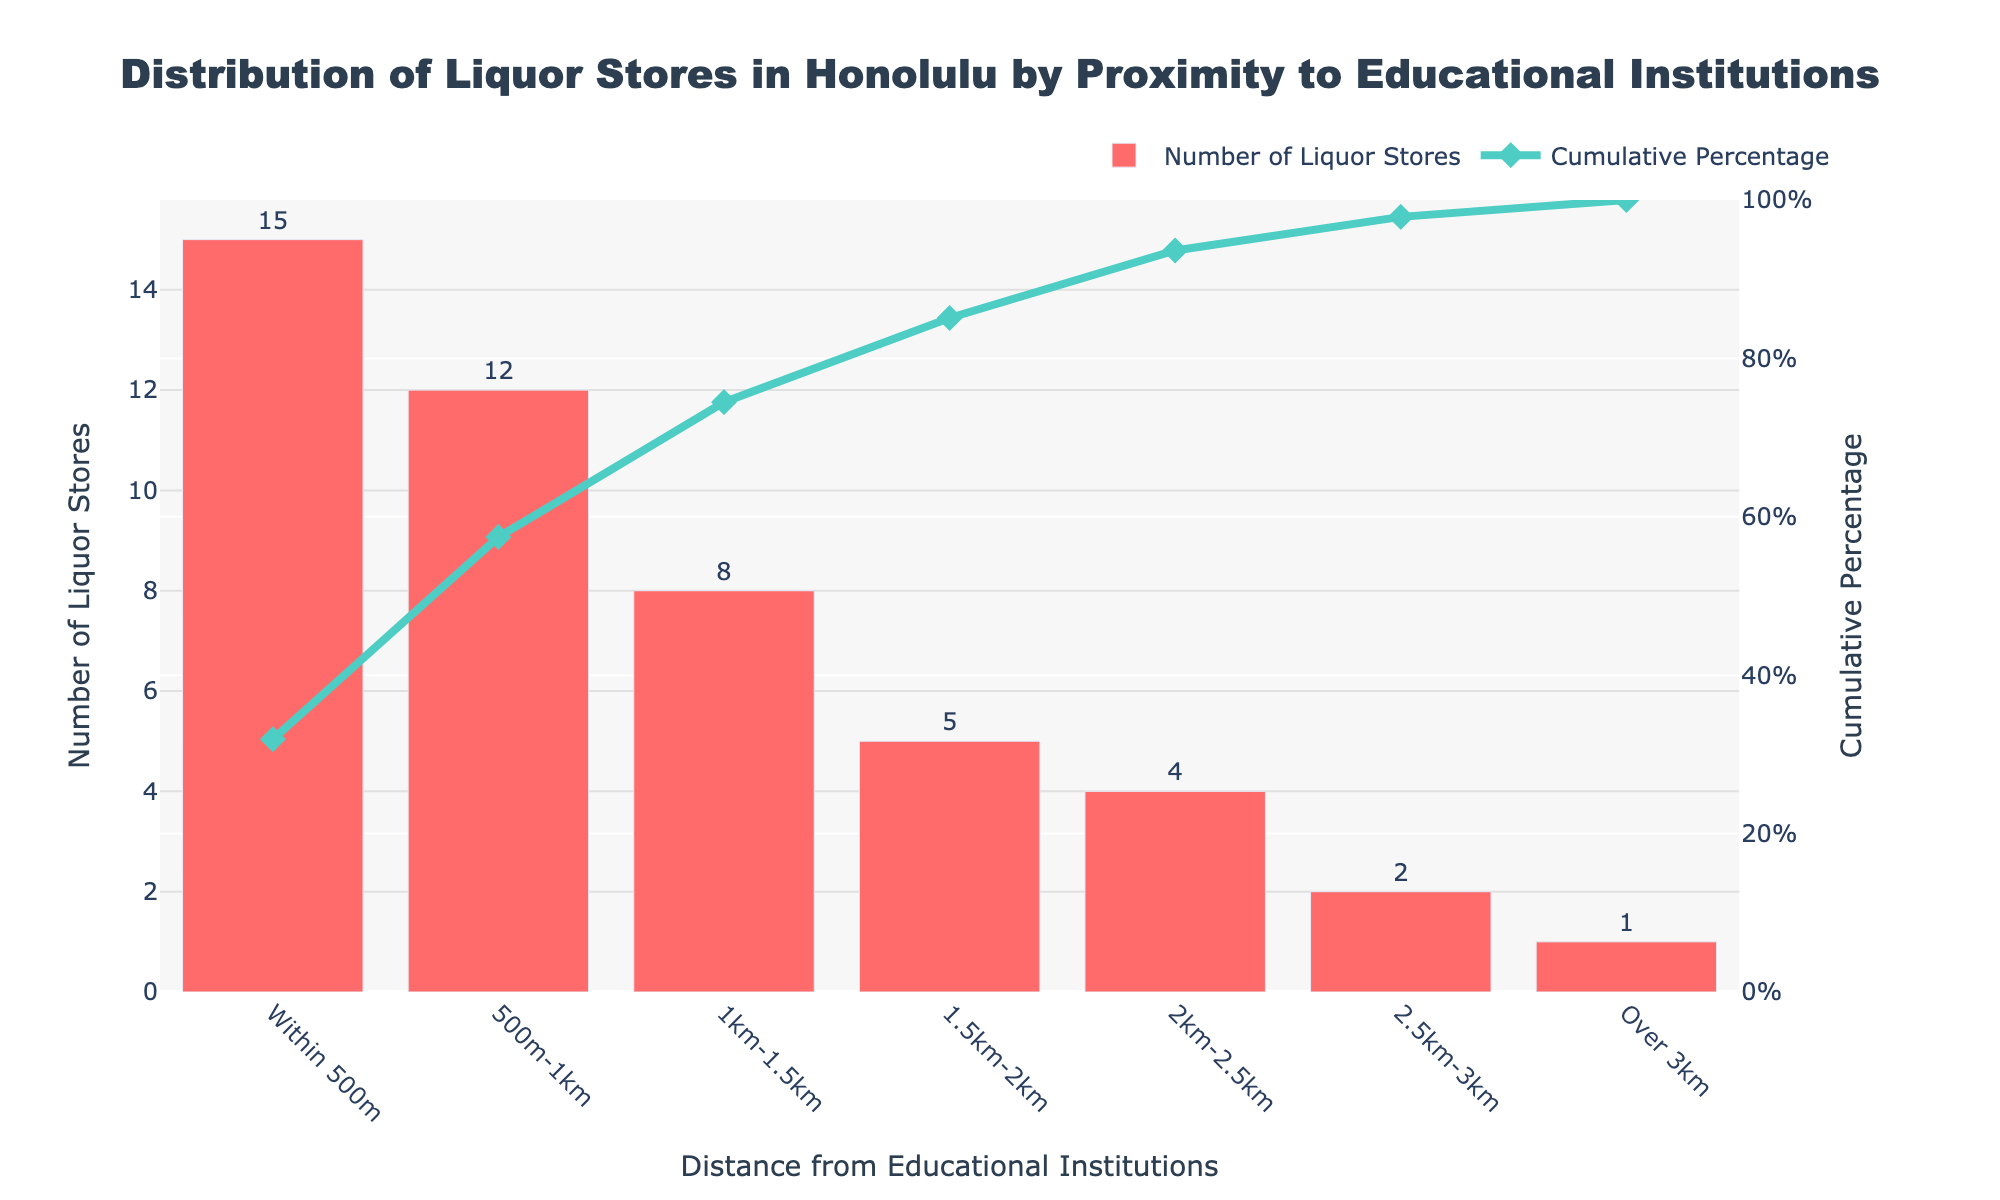What is the title of the figure? The title of the figure is generally located at the top and summarizes the main topic. Here, it is "Distribution of Liquor Stores in Honolulu by Proximity to Educational Institutions".
Answer: Distribution of Liquor Stores in Honolulu by Proximity to Educational Institutions How many liquor stores are within 500 meters of educational institutions? The number of liquor stores within 500 meters is represented by the bar corresponding to "Within 500m". This bar shows the number "15".
Answer: 15 What is the cumulative percentage of liquor stores located within 1 kilometer? The cumulative percentage within 1 kilometer can be found by looking at the cumulative line at "500m-1km". The value indicated is "57.45%".
Answer: 57.45% How does the number of liquor stores change as the distance from educational institutions increases from within 500m to 2.5km? Look at the bars corresponding to distances "Within 500m", "500m-1km", "1km-1.5km", "1.5km-2km", and "2km-2.5km". They represent the number of liquor stores as 15, 12, 8, 5, and 4, respectively, indicating a decreasing trend.
Answer: Decreases What is the total number of liquor stores shown in the figure? Sum up the number of liquor stores across all distances: 15 + 12 + 8 + 5 + 4 + 2 + 1 = 47.
Answer: 47 Between which distances does the number of liquor stores drop by the largest amount? Compare the differences between consecutive bars:
- From "Within 500m" to "500m-1km": 15 - 12 = 3
- From "500m-1km" to "1km-1.5km": 12 - 8 = 4
- From "1km-1.5km" to "1.5km-2km": 8 - 5 = 3
- From "1.5km-2km" to "2km-2.5km": 5 - 4 = 1
- From "2.5km-3km" to "Over 3km": 2 - 1 = 1
The largest drop is between "500m-1km" and "1km-1.5km".
Answer: 500m-1km to 1km-1.5km Which distance category has the highest cumulative percentage? The highest cumulative percentage is always the last category listed, which is "Over 3km" with "100.00%".
Answer: Over 3km What is the cumulative percentage of liquor stores located within 2 kilometers from educational institutions? Sum the cumulative percentages for the categories up to "1.5km-2km", the last value given under 2 kilometers. This shows "85.11%".
Answer: 85.11% Is the number of liquor stores in the "2.5km-3km" distance category higher than the "Over 3km" category? Compare the bar heights or values: "2.5km-3km" has 2 liquor stores, while "Over 3km" has 1 liquor store. Thus, 2 > 1.
Answer: Yes 